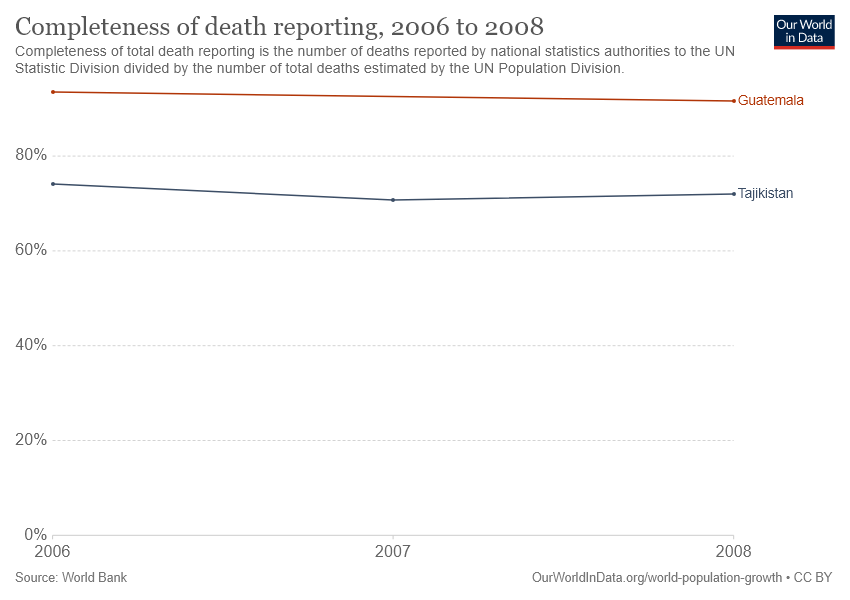Identify some key points in this picture. The chart includes information on two countries. The gap between the two countries became the largest in 2007. 